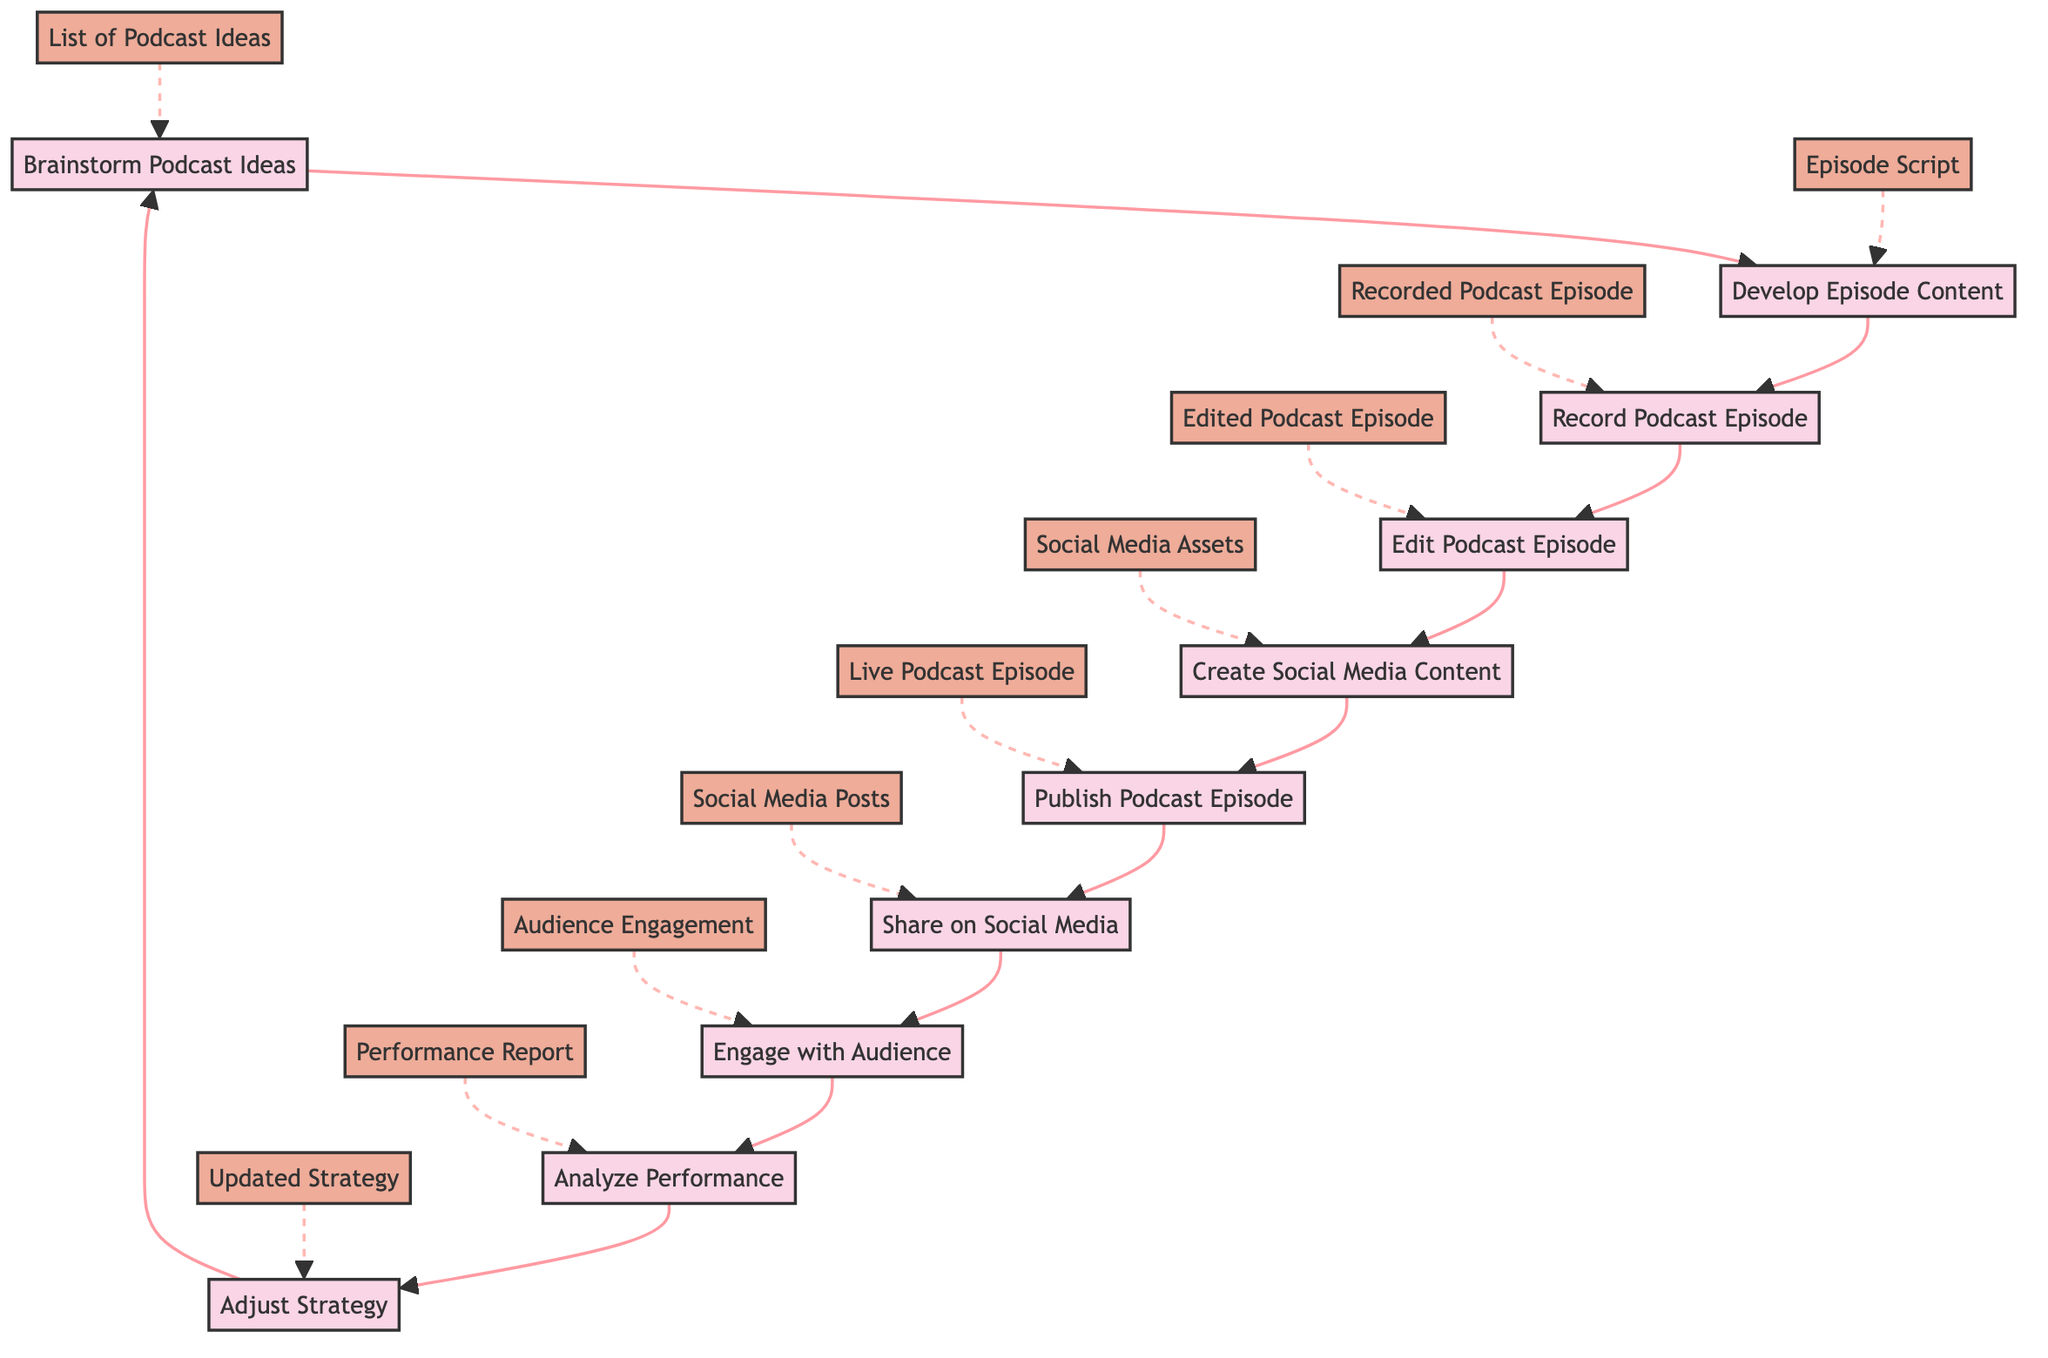What's the first activity in the diagram? The diagram starts with the node labeled "Brainstorm Podcast Ideas," which is the first activity.
Answer: Brainstorm Podcast Ideas How many main activities are depicted in the diagram? By counting the number of labeled activities, there are ten main activities shown in the diagram.
Answer: 10 What is the output of the "Publish Podcast Episode" activity? The output associated with the "Publish Podcast Episode" node is "Live Podcast Episode."
Answer: Live Podcast Episode Which participants are involved in creating social media content? According to the diagram, the participants listed for the "Create Social Media Content" activity are the Content Strategist, Graphic Designer, and Social Media Manager.
Answer: Content Strategist, Graphic Designer, Social Media Manager What is the relationship between "Analyze Performance" and "Adjust Strategy"? "Analyze Performance" leads to "Adjust Strategy," indicating that the performance analysis is a prerequisite for adjusting the strategy based on its outcomes.
Answer: Adjust Strategy follows Analyze Performance How many outputs are connected to the "Engage with Audience" activity? There is one direct output from the "Engage with Audience" activity, which is labeled "Audience Engagement."
Answer: 1 What is the last activity before "Analyze Performance"? The last activity that occurs before "Analyze Performance" is "Engage with Audience," which indicates the flow of activities before performance analysis begins.
Answer: Engage with Audience Who is the sole participant involved in editing the podcast episode? The "Edit Podcast Episode" node specifies that the only participant for this activity is the Audio Engineer.
Answer: Audio Engineer Which phase includes audience interaction? The "Engage with Audience" activity is the phase that includes interaction with the audience through responding to comments and questions on social media.
Answer: Engage with Audience What activity follows "Share on Social Media"? The activity following "Share on Social Media" in the flow is "Engage with Audience," suggesting that sharing leads directly to audience engagement activities.
Answer: Engage with Audience 